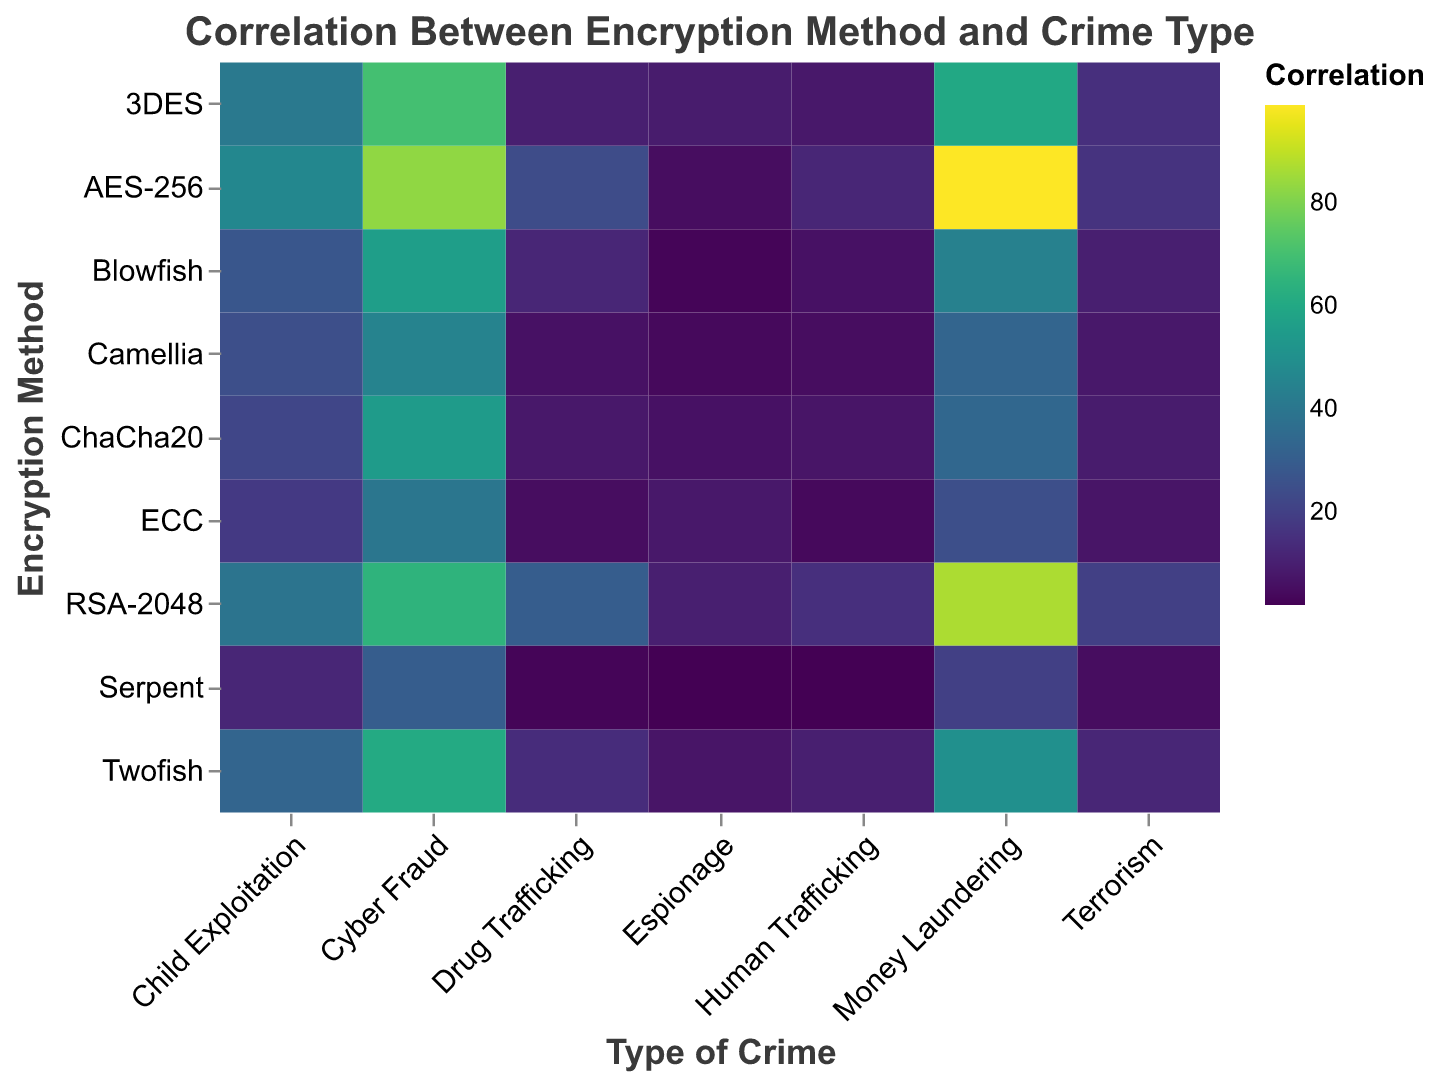What is the most frequently used encryption method for Cyber Fraud? Look for the crypto method with the darkest/highest colored cell under the "Cyber Fraud" column. AES-256 has a value of 83, which is the highest.
Answer: AES-256 Which encryption method has the least amount of usage in Drug Trafficking? Check for the lightest color or lowest numeric value in the "Drug Trafficking" column. Serpent has the lowest value with a 3.
Answer: Serpent How many total cases of Child Exploitation are recorded with RSA-2048 encryption? Find the cell at the intersection of "RSA-2048" and "Child Exploitation," which has a value of 39.
Answer: 39 Compare the usage of AES-256 and 3DES in Money Laundering. Which one is used more, and what’s the difference in their usage? Look at the Money Laundering column for AES-256 and 3DES. AES-256 is 99 and 3DES is 60. The difference is 99 - 60 = 39.
Answer: AES-256, with a difference of 39 What is the average number of crimes for the encryption method Blowfish across all crime types? Sum the values for Blowfish across all crime types (12+56+6+28+10+44+3 = 159) and then divide by the number of crime types (7). 159 / 7 ≈ 22.71
Answer: ≈22.71 Which type of crime has the highest occurrence recorded for the encryption method ChaCha20? Look for the darkest/highest colored cell in the row for ChaCha20. Cyber Fraud has the highest value with 55.
Answer: Cyber Fraud For the encryption method ECC, what is the combined number of cases for Cyber Fraud and Money Laundering? Add the values for ECC in the Cyber Fraud (40) and Money Laundering (25) columns. 40 + 25 = 65.
Answer: 65 Compare and identify which encryption method has more Human Trafficking cases: Twofish or Camellia? Look at the figures for Human Trafficking in the Twofish row (10) and Camellia row (5). Twofish has more cases.
Answer: Twofish What is the correlation value for the Espionage crime type when the Serpent encryption method is used? Find the value at the intersection of Espionage and Serpent, which is 2.
Answer: 2 Identify the crime type that has the smallest variation in values across all encryption methods. Look across all columns and compare the range (max-min) for each crime type. Espionage has the smallest variation: range from 2 (Serpent) to 10 (RSA-2048) which is 8.
Answer: Espionage 